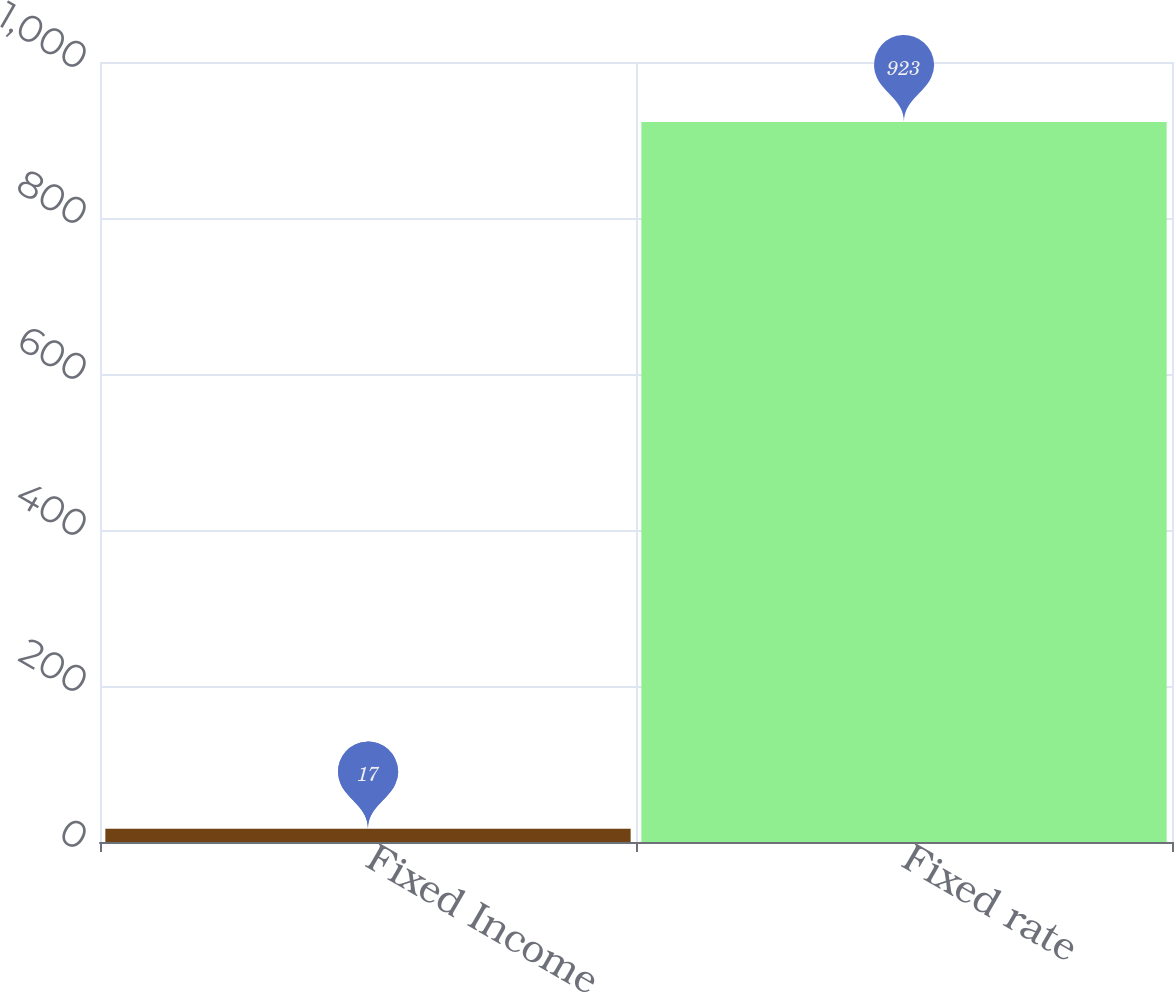Convert chart. <chart><loc_0><loc_0><loc_500><loc_500><bar_chart><fcel>Fixed Income<fcel>Fixed rate<nl><fcel>17<fcel>923<nl></chart> 